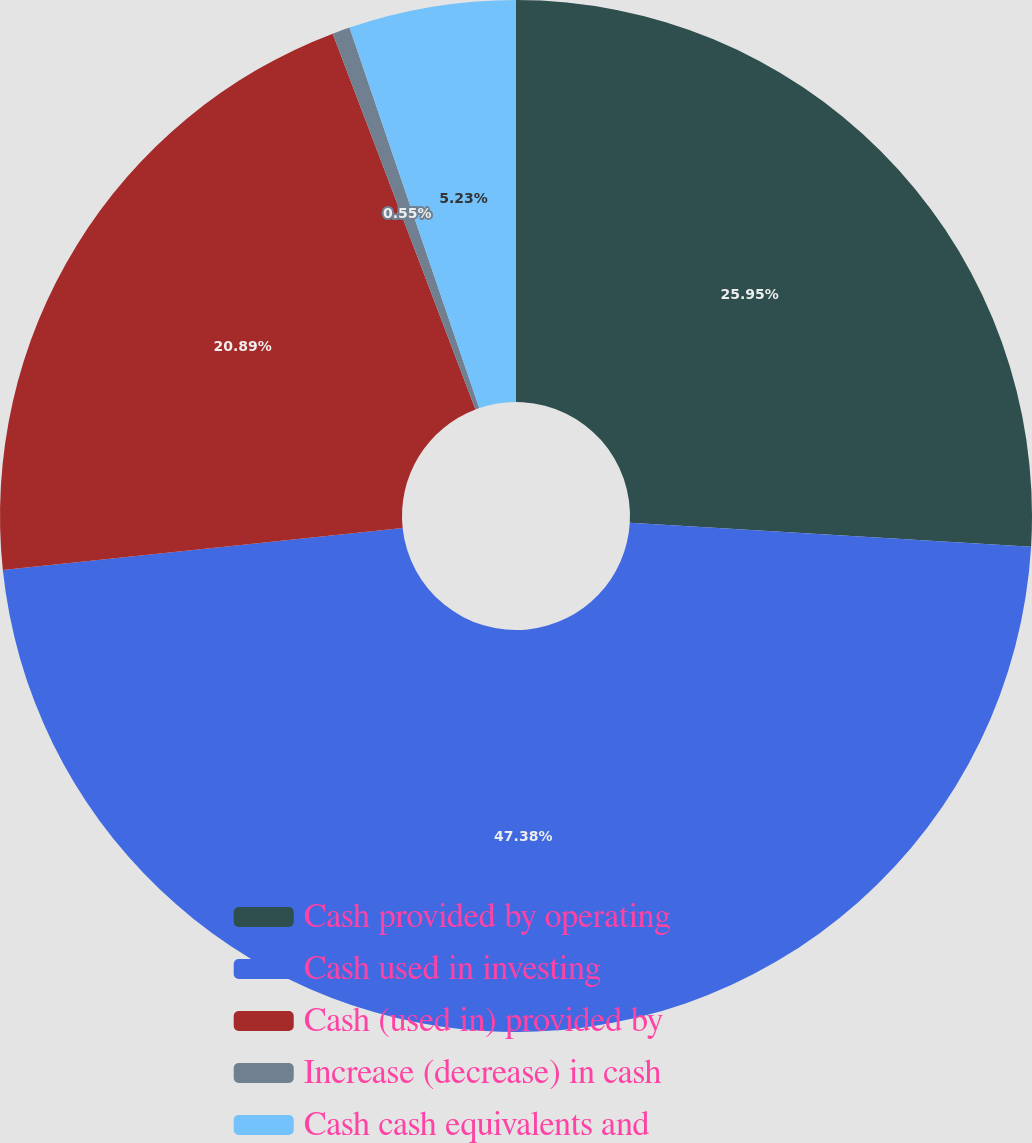<chart> <loc_0><loc_0><loc_500><loc_500><pie_chart><fcel>Cash provided by operating<fcel>Cash used in investing<fcel>Cash (used in) provided by<fcel>Increase (decrease) in cash<fcel>Cash cash equivalents and<nl><fcel>25.95%<fcel>47.39%<fcel>20.89%<fcel>0.55%<fcel>5.23%<nl></chart> 